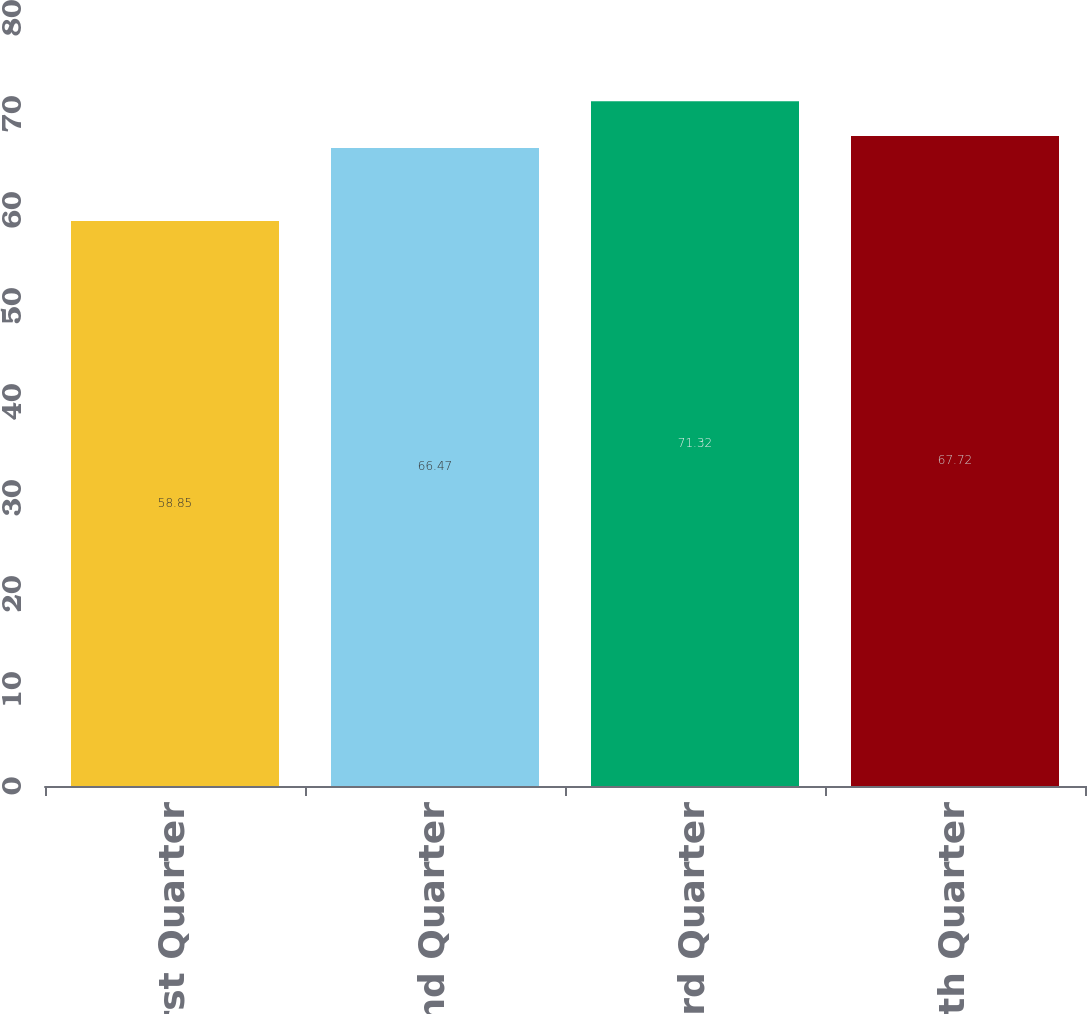<chart> <loc_0><loc_0><loc_500><loc_500><bar_chart><fcel>First Quarter<fcel>Second Quarter<fcel>Third Quarter<fcel>Fourth Quarter<nl><fcel>58.85<fcel>66.47<fcel>71.32<fcel>67.72<nl></chart> 